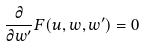Convert formula to latex. <formula><loc_0><loc_0><loc_500><loc_500>\frac { \partial } { \partial w ^ { \prime } } F ( u , w , w ^ { \prime } ) = 0</formula> 